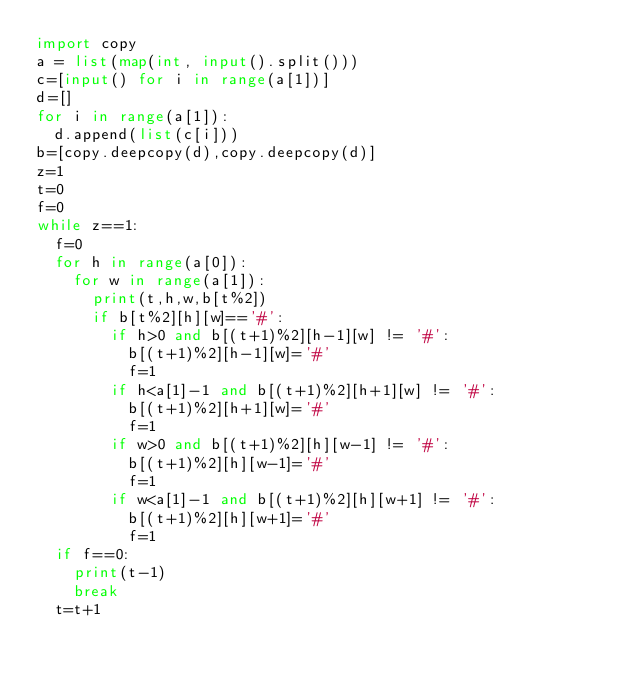<code> <loc_0><loc_0><loc_500><loc_500><_Python_>import copy
a = list(map(int, input().split()))
c=[input() for i in range(a[1])]
d=[]
for i in range(a[1]):
  d.append(list(c[i]))
b=[copy.deepcopy(d),copy.deepcopy(d)]
z=1
t=0
f=0
while z==1:
  f=0
  for h in range(a[0]):
    for w in range(a[1]):
      print(t,h,w,b[t%2])
      if b[t%2][h][w]=='#':
        if h>0 and b[(t+1)%2][h-1][w] != '#':
          b[(t+1)%2][h-1][w]='#'
          f=1
        if h<a[1]-1 and b[(t+1)%2][h+1][w] != '#':          
          b[(t+1)%2][h+1][w]='#'
          f=1
        if w>0 and b[(t+1)%2][h][w-1] != '#':  
          b[(t+1)%2][h][w-1]='#'
          f=1
        if w<a[1]-1 and b[(t+1)%2][h][w+1] != '#':   
          b[(t+1)%2][h][w+1]='#'
          f=1
  if f==0:
    print(t-1)
    break
  t=t+1 </code> 